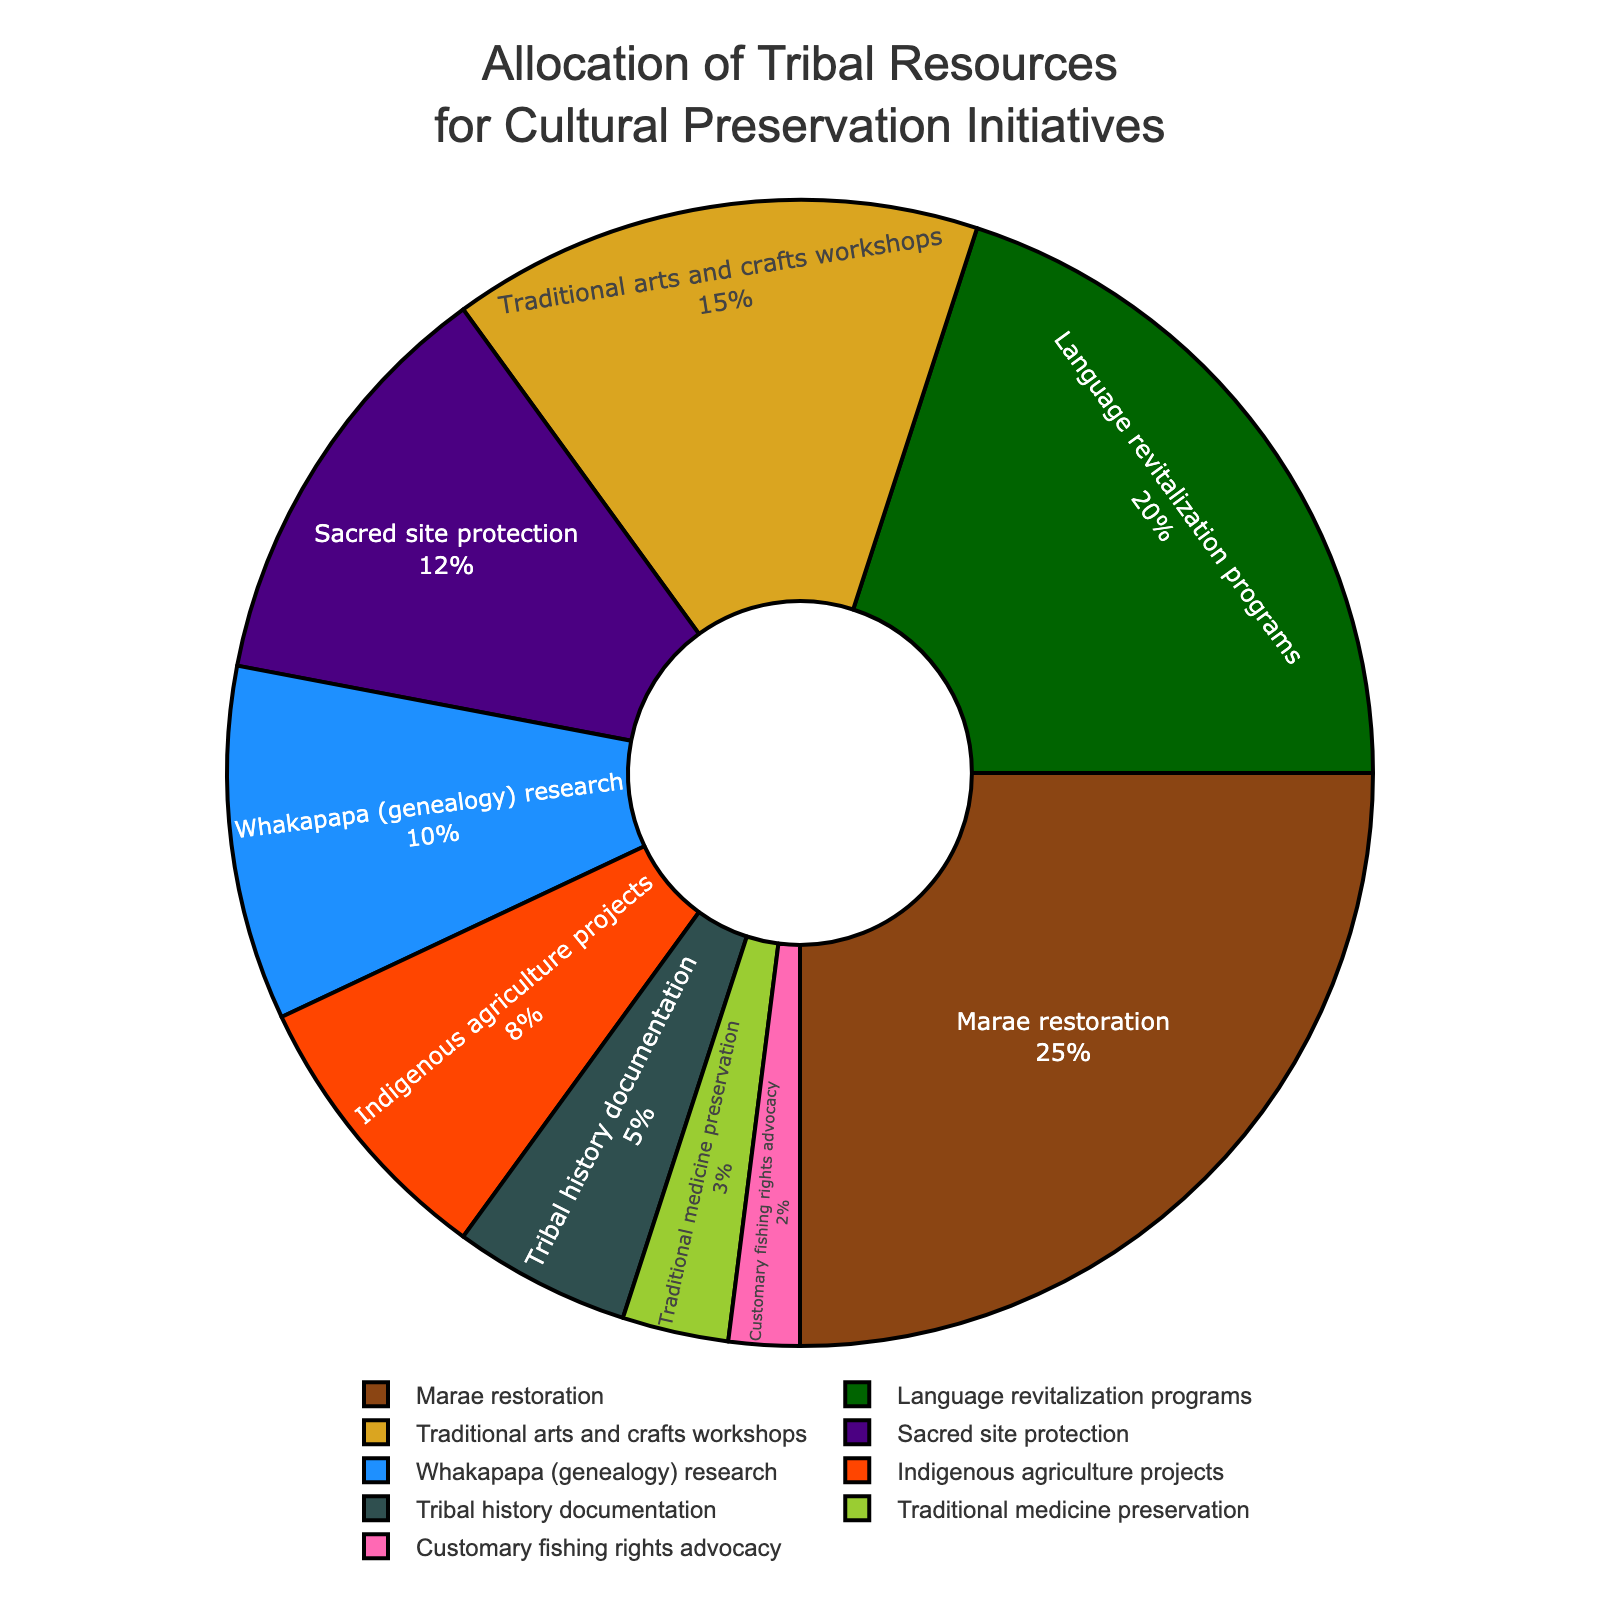What is the initiative receiving the highest allocation of tribal resources? The pie chart shows various initiatives and their respective percentages. By looking at the slices, "Marae restoration" has the largest slice with 25%.
Answer: Marae restoration How much more percentage is allocated to Language revitalization programs compared to Traditional medicine preservation? The chart indicates "Language revitalization programs" is allocated 20%, and "Traditional medicine preservation" is allocated 3%. Subtracting the smaller percentage from the larger one, 20% - 3%, gives the difference.
Answer: 17% What is the combined percentage allocated to Sacred site protection and Whakapapa (genealogy) research? To find the combined percentage, add the allocation for "Sacred site protection" (12%) and "Whakapapa (genealogy) research" (10%). The calculation is 12% + 10%.
Answer: 22% Which initiative has a lesser allocation: Indigenous agriculture projects or Tribal history documentation? By comparing the slices, "Indigenous agriculture projects" has 8%, and "Tribal history documentation" has 5%.
Answer: Tribal history documentation What color represents Traditional arts and crafts workshops? The chart uses various colors for each initiative. The slice for "Traditional arts and crafts workshops" is colored in gold.
Answer: Gold How does the allocation for Customary fishing rights advocacy compare to Sacred site protection? "Customary fishing rights advocacy" has 2%, whereas "Sacred site protection" has a larger slice with 12%.
Answer: Less What is the total percentage allocated to Traditional medicine preservation, Tribal history documentation, and Customary fishing rights advocacy combined? The allocations are 3%, 5%, and 2% respectively. Summing them up: 3% + 5% + 2%.
Answer: 10% Which initiative falls between the 15% and 20% allocation range? Reviewing the chart, "Traditional arts and crafts workshops" has 15%, and "Language revitalization programs" has 20%, so "Traditional arts and crafts workshops" falls between the 15% to 20% range.
Answer: Traditional arts and crafts workshops How much more is allocated to Marae restoration compared to Indigenous agriculture projects? Compare the allocations: "Marae restoration" has 25%, and "Indigenous agriculture projects" has 8%. The difference is 25% - 8%.
Answer: 17% 